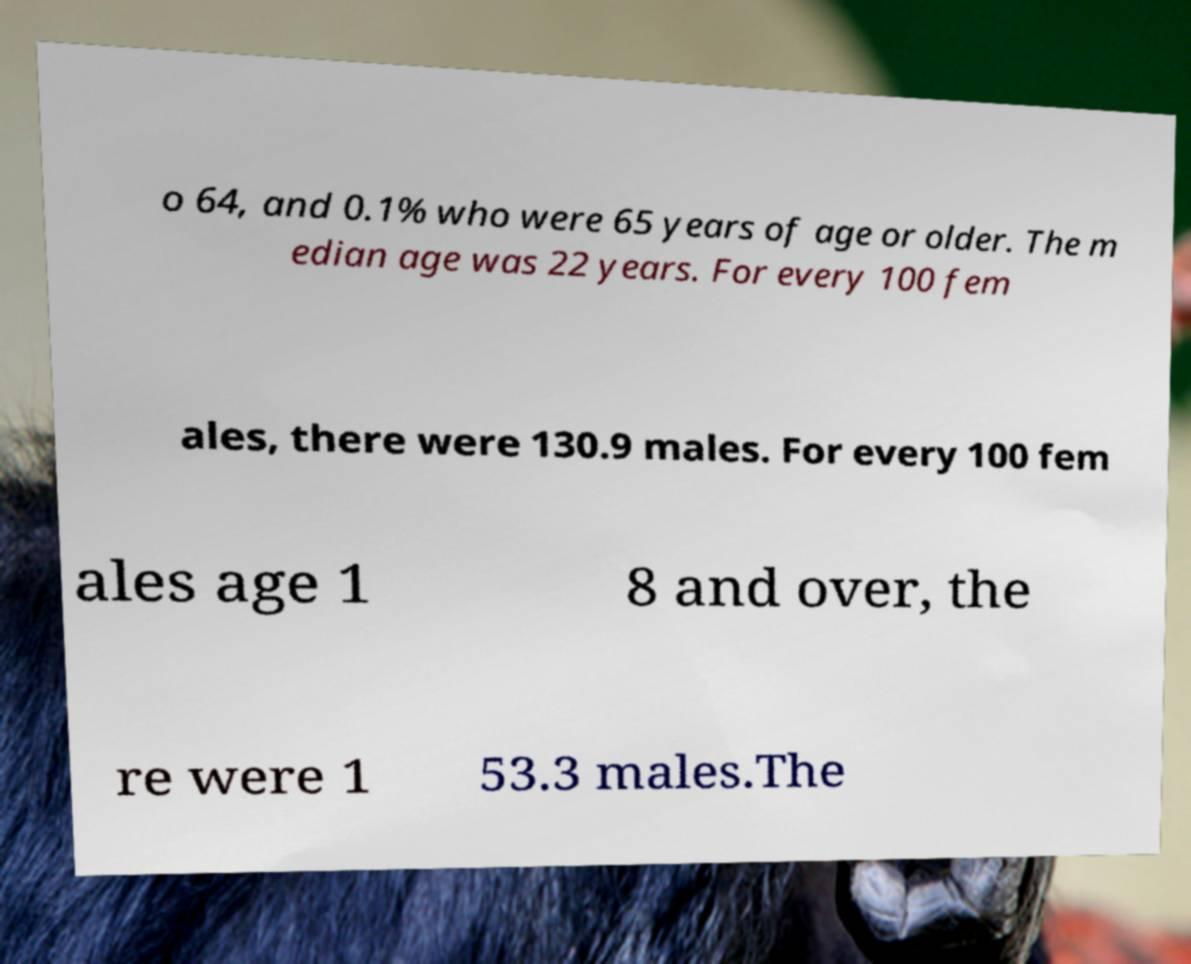There's text embedded in this image that I need extracted. Can you transcribe it verbatim? o 64, and 0.1% who were 65 years of age or older. The m edian age was 22 years. For every 100 fem ales, there were 130.9 males. For every 100 fem ales age 1 8 and over, the re were 1 53.3 males.The 